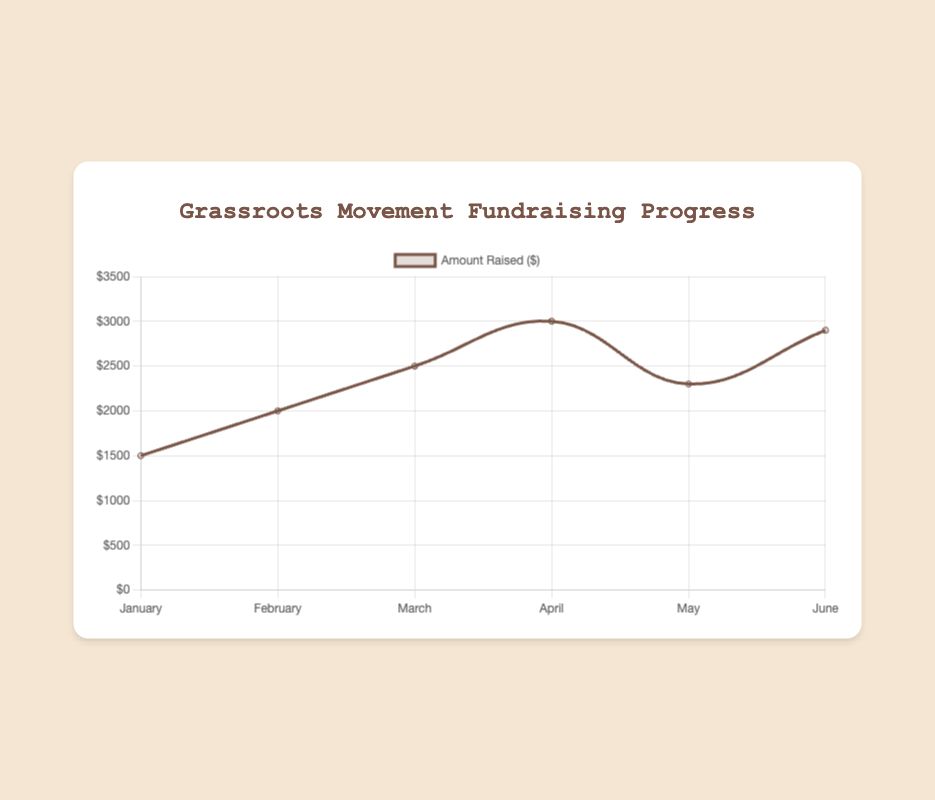What is the total amount raised over the 6 months? Add the amounts raised each month: 1500 + 2000 + 2500 + 3000 + 2300 + 2900 = 14200
Answer: 14200 In which month was the lowest amount raised? Look at the line plot and identify the lowest point on the graph; here, the lowest point is in January with $1500 raised.
Answer: January What is the average amount raised per month? Sum the amounts raised for all months and divide by the number of months: (1500 + 2000 + 2500 + 3000 + 2300 + 2900) / 6 = 14200 / 6 ≈ 2366.67
Answer: 2366.67 Which month had a higher amount raised: April or May? Compare the amounts raised in April and May from the plot: April ($3000) versus May ($2300).
Answer: April What is the difference in the amount raised between March and June? Find the amounts for March and June and subtract: 2900 (June) - 2500 (March) = 400
Answer: 400 Which month showed the greatest increase in fundraising compared to the previous month? Calculate the difference in amount raised between consecutive months and find the maximum: February - January = 500, March - February = 500, April - March = 500, May - April = -700, June - May = 600. The greatest increase is from May to June.
Answer: June How many months had an amount raised of over $2500? Count the months where the amount raised exceeds $2500: March ($2500), April ($3000), and June ($2900). There are 3 months.
Answer: 3 Which month represents the peak amount raised and how much was it? Identify the highest point on the graph: April with $3000 raised.
Answer: April, 3000 Does the trend line show a consistent increase, decrease, or fluctuation in the amount raised over the months? Observe the line plot; it shows fluctuation instead of a consistent increase or decrease.
Answer: Fluctuation What portion of the total fundraising contributions were raised in February? Calculate the percentage of total: (2000 / 14200) * 100 ≈ 14.08%
Answer: ~14.08% 